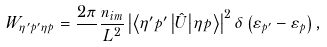Convert formula to latex. <formula><loc_0><loc_0><loc_500><loc_500>W _ { \eta ^ { \prime } { p } ^ { \prime } \eta { p } } = \frac { 2 \pi } { } \frac { n _ { i m } } { L ^ { 2 } } \left | \left \langle \eta ^ { \prime } { p } ^ { \prime } \left | { \hat { U } } \right | \eta { p } \right \rangle \right | ^ { 2 } \delta \left ( \varepsilon _ { p ^ { \prime } } - \varepsilon _ { p } \right ) ,</formula> 